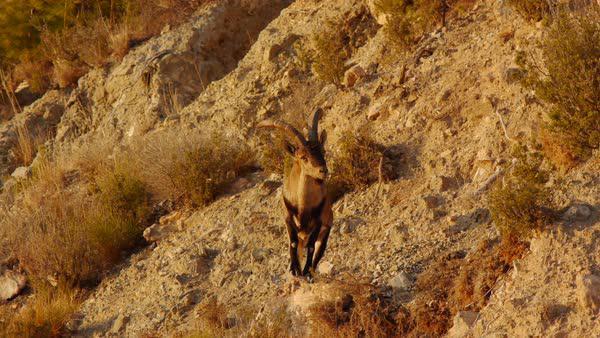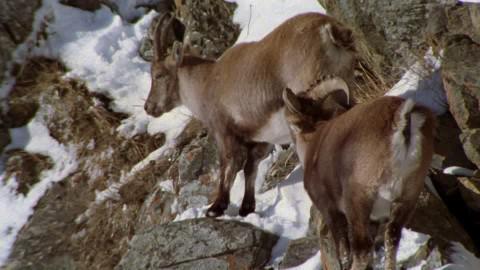The first image is the image on the left, the second image is the image on the right. Considering the images on both sides, is "An image shows two hooved animals on a rocky mountainside with patches of white snow." valid? Answer yes or no. Yes. The first image is the image on the left, the second image is the image on the right. Evaluate the accuracy of this statement regarding the images: "The animals in the image on the right are on a snowy rocky cliff.". Is it true? Answer yes or no. Yes. 